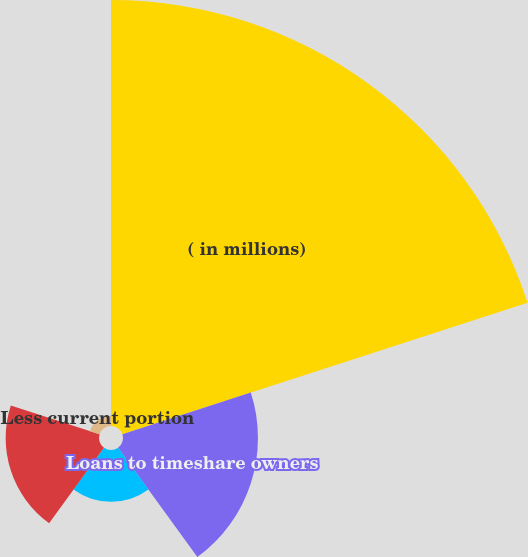Convert chart to OTSL. <chart><loc_0><loc_0><loc_500><loc_500><pie_chart><fcel>( in millions)<fcel>Loans to timeshare owners<fcel>Lodging senior loans<fcel>Lodging mezzanine and other<fcel>Less current portion<nl><fcel>59.47%<fcel>18.84%<fcel>7.23%<fcel>13.03%<fcel>1.42%<nl></chart> 